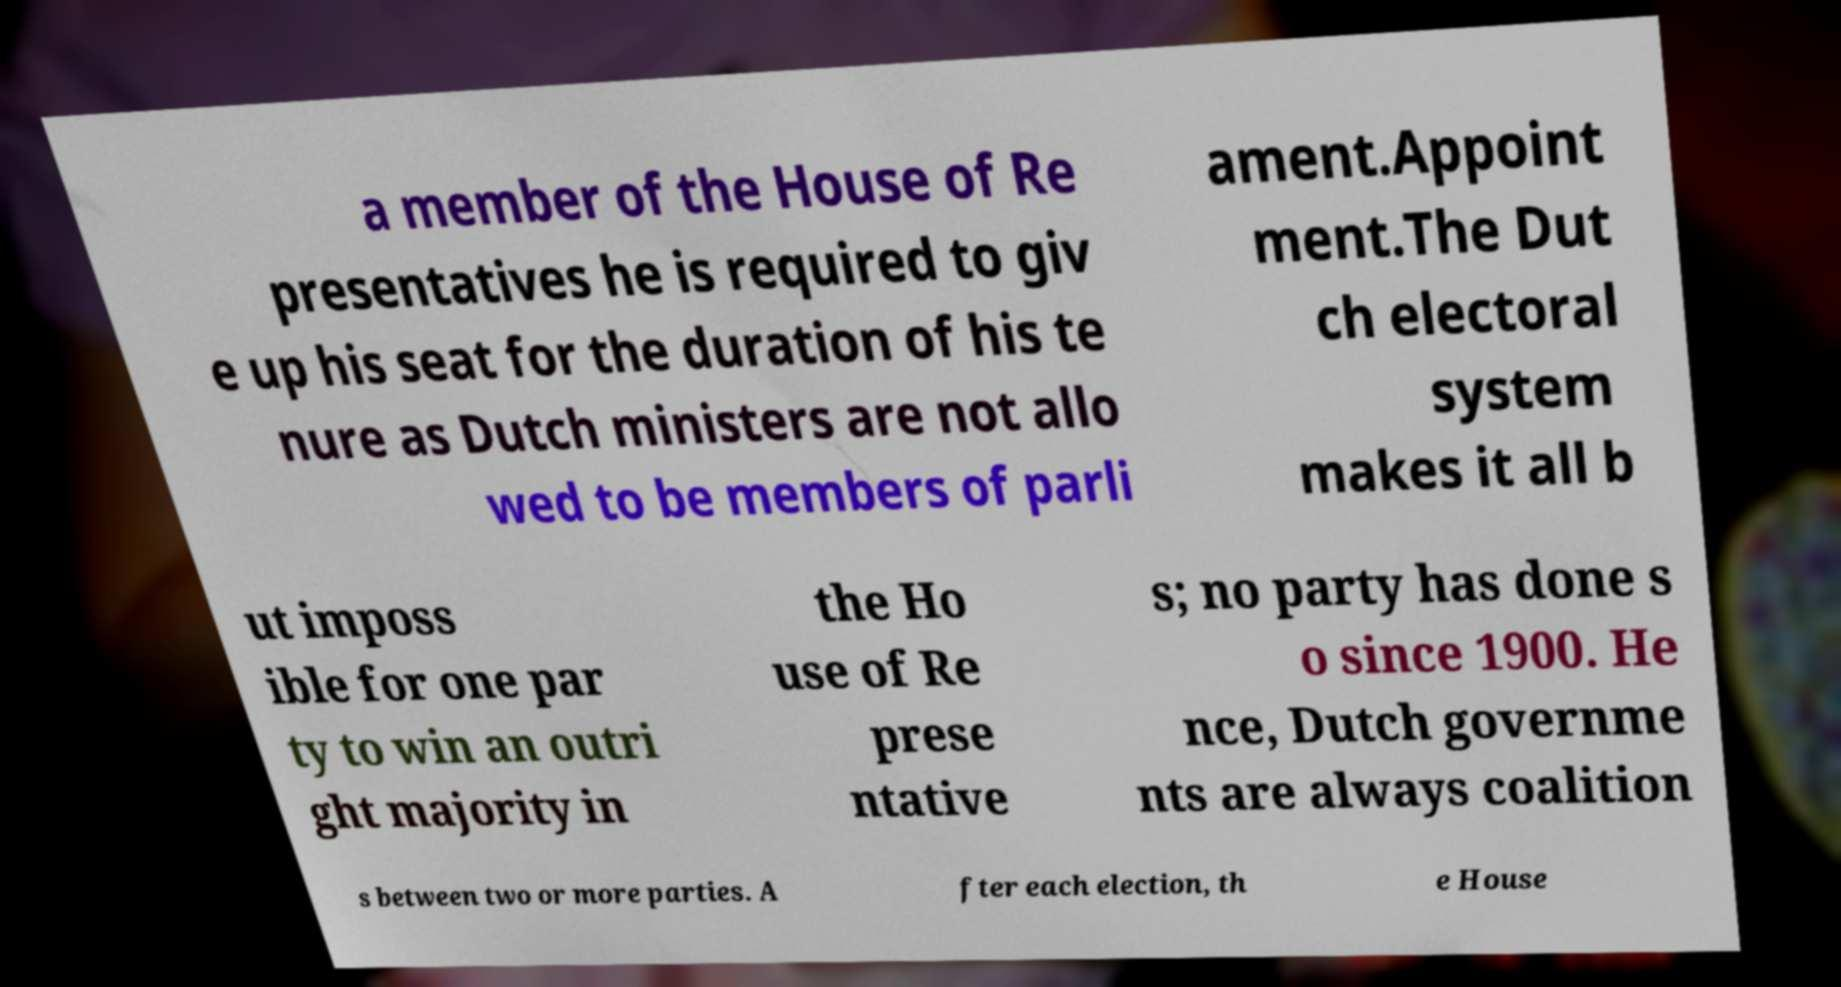What messages or text are displayed in this image? I need them in a readable, typed format. a member of the House of Re presentatives he is required to giv e up his seat for the duration of his te nure as Dutch ministers are not allo wed to be members of parli ament.Appoint ment.The Dut ch electoral system makes it all b ut imposs ible for one par ty to win an outri ght majority in the Ho use of Re prese ntative s; no party has done s o since 1900. He nce, Dutch governme nts are always coalition s between two or more parties. A fter each election, th e House 